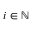Convert formula to latex. <formula><loc_0><loc_0><loc_500><loc_500>i \in \mathbb { N }</formula> 